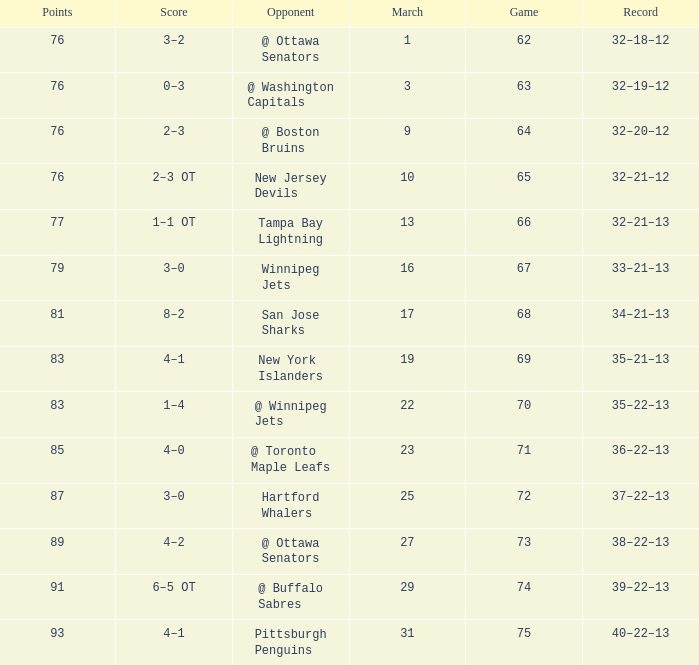How much March has Points of 85? 1.0. 